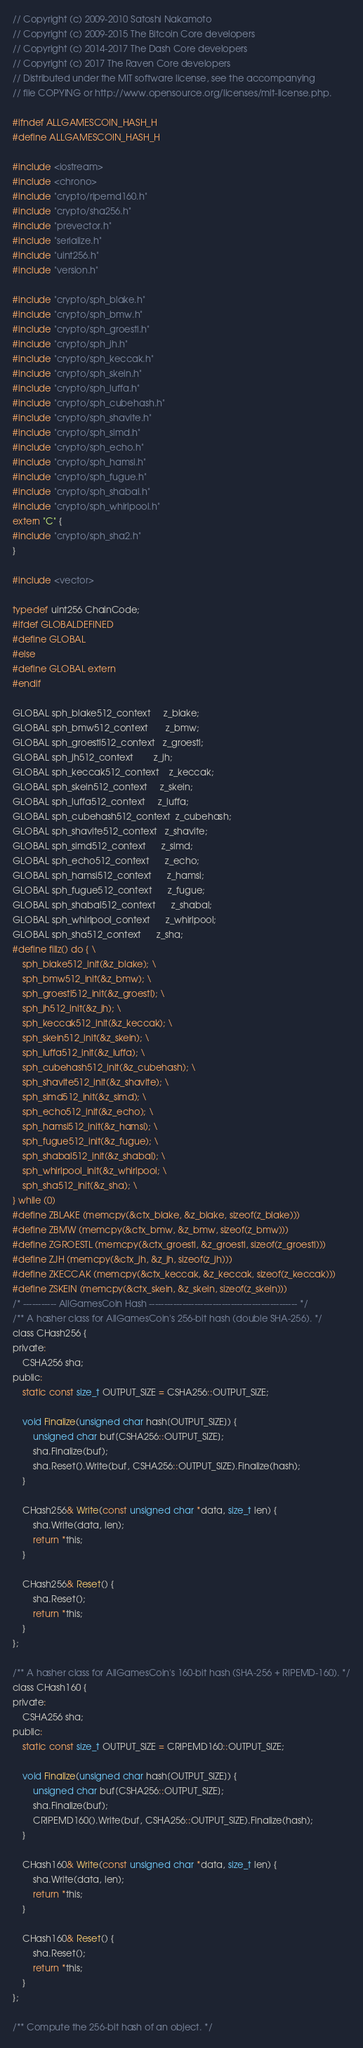<code> <loc_0><loc_0><loc_500><loc_500><_C_>// Copyright (c) 2009-2010 Satoshi Nakamoto
// Copyright (c) 2009-2015 The Bitcoin Core developers
// Copyright (c) 2014-2017 The Dash Core developers
// Copyright (c) 2017 The Raven Core developers
// Distributed under the MIT software license, see the accompanying
// file COPYING or http://www.opensource.org/licenses/mit-license.php.

#ifndef ALLGAMESCOIN_HASH_H
#define ALLGAMESCOIN_HASH_H

#include <iostream>
#include <chrono>
#include "crypto/ripemd160.h"
#include "crypto/sha256.h"
#include "prevector.h"
#include "serialize.h"
#include "uint256.h"
#include "version.h"

#include "crypto/sph_blake.h"
#include "crypto/sph_bmw.h"
#include "crypto/sph_groestl.h"
#include "crypto/sph_jh.h"
#include "crypto/sph_keccak.h"
#include "crypto/sph_skein.h"
#include "crypto/sph_luffa.h"
#include "crypto/sph_cubehash.h"
#include "crypto/sph_shavite.h"
#include "crypto/sph_simd.h"
#include "crypto/sph_echo.h"
#include "crypto/sph_hamsi.h"
#include "crypto/sph_fugue.h"
#include "crypto/sph_shabal.h"
#include "crypto/sph_whirlpool.h"
extern "C" {
#include "crypto/sph_sha2.h"
}

#include <vector>

typedef uint256 ChainCode;
#ifdef GLOBALDEFINED
#define GLOBAL
#else
#define GLOBAL extern
#endif

GLOBAL sph_blake512_context     z_blake;
GLOBAL sph_bmw512_context       z_bmw;
GLOBAL sph_groestl512_context   z_groestl;
GLOBAL sph_jh512_context        z_jh;
GLOBAL sph_keccak512_context    z_keccak;
GLOBAL sph_skein512_context     z_skein;
GLOBAL sph_luffa512_context     z_luffa;
GLOBAL sph_cubehash512_context  z_cubehash;
GLOBAL sph_shavite512_context   z_shavite;
GLOBAL sph_simd512_context      z_simd;
GLOBAL sph_echo512_context      z_echo;
GLOBAL sph_hamsi512_context      z_hamsi;
GLOBAL sph_fugue512_context      z_fugue;
GLOBAL sph_shabal512_context      z_shabal;
GLOBAL sph_whirlpool_context      z_whirlpool;
GLOBAL sph_sha512_context      z_sha;
#define fillz() do { \
    sph_blake512_init(&z_blake); \
    sph_bmw512_init(&z_bmw); \
    sph_groestl512_init(&z_groestl); \
    sph_jh512_init(&z_jh); \
    sph_keccak512_init(&z_keccak); \
    sph_skein512_init(&z_skein); \
    sph_luffa512_init(&z_luffa); \
    sph_cubehash512_init(&z_cubehash); \
    sph_shavite512_init(&z_shavite); \
    sph_simd512_init(&z_simd); \
    sph_echo512_init(&z_echo); \
    sph_hamsi512_init(&z_hamsi); \
    sph_fugue512_init(&z_fugue); \
    sph_shabal512_init(&z_shabal); \
    sph_whirlpool_init(&z_whirlpool; \
    sph_sha512_init(&z_sha); \
} while (0)
#define ZBLAKE (memcpy(&ctx_blake, &z_blake, sizeof(z_blake)))
#define ZBMW (memcpy(&ctx_bmw, &z_bmw, sizeof(z_bmw)))
#define ZGROESTL (memcpy(&ctx_groestl, &z_groestl, sizeof(z_groestl)))
#define ZJH (memcpy(&ctx_jh, &z_jh, sizeof(z_jh)))
#define ZKECCAK (memcpy(&ctx_keccak, &z_keccak, sizeof(z_keccak)))
#define ZSKEIN (memcpy(&ctx_skein, &z_skein, sizeof(z_skein)))
/* ----------- AllGamesCoin Hash ------------------------------------------------- */
/** A hasher class for AllGamesCoin's 256-bit hash (double SHA-256). */
class CHash256 {
private:
    CSHA256 sha;
public:
    static const size_t OUTPUT_SIZE = CSHA256::OUTPUT_SIZE;

    void Finalize(unsigned char hash[OUTPUT_SIZE]) {
        unsigned char buf[CSHA256::OUTPUT_SIZE];
        sha.Finalize(buf);
        sha.Reset().Write(buf, CSHA256::OUTPUT_SIZE).Finalize(hash);
    }

    CHash256& Write(const unsigned char *data, size_t len) {
        sha.Write(data, len);
        return *this;
    }

    CHash256& Reset() {
        sha.Reset();
        return *this;
    }
};

/** A hasher class for AllGamesCoin's 160-bit hash (SHA-256 + RIPEMD-160). */
class CHash160 {
private:
    CSHA256 sha;
public:
    static const size_t OUTPUT_SIZE = CRIPEMD160::OUTPUT_SIZE;

    void Finalize(unsigned char hash[OUTPUT_SIZE]) {
        unsigned char buf[CSHA256::OUTPUT_SIZE];
        sha.Finalize(buf);
        CRIPEMD160().Write(buf, CSHA256::OUTPUT_SIZE).Finalize(hash);
    }

    CHash160& Write(const unsigned char *data, size_t len) {
        sha.Write(data, len);
        return *this;
    }

    CHash160& Reset() {
        sha.Reset();
        return *this;
    }
};

/** Compute the 256-bit hash of an object. */</code> 